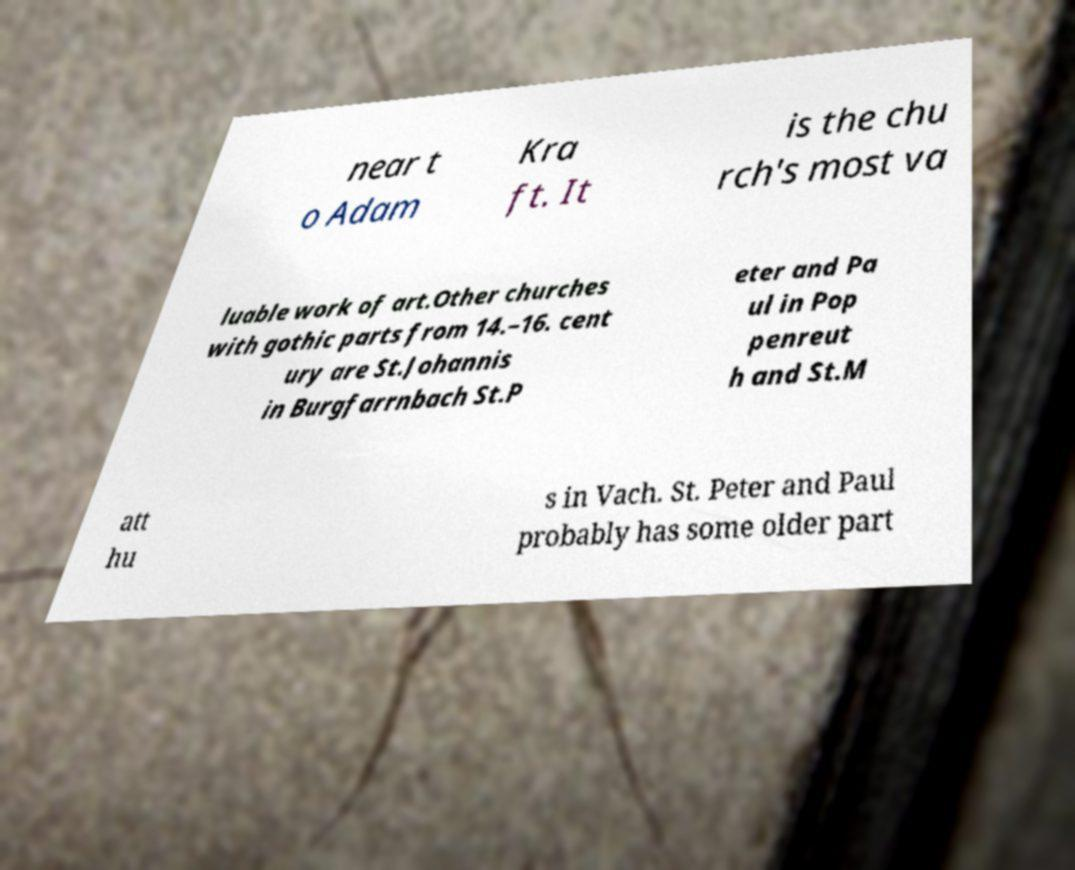What messages or text are displayed in this image? I need them in a readable, typed format. near t o Adam Kra ft. It is the chu rch's most va luable work of art.Other churches with gothic parts from 14.–16. cent ury are St.Johannis in Burgfarrnbach St.P eter and Pa ul in Pop penreut h and St.M att hu s in Vach. St. Peter and Paul probably has some older part 